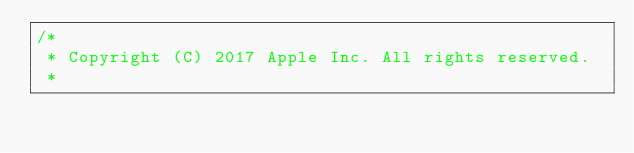Convert code to text. <code><loc_0><loc_0><loc_500><loc_500><_ObjectiveC_>/*
 * Copyright (C) 2017 Apple Inc. All rights reserved.
 *</code> 